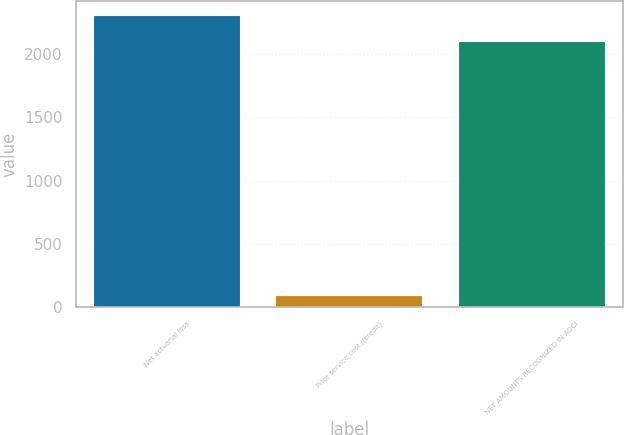<chart> <loc_0><loc_0><loc_500><loc_500><bar_chart><fcel>Net actuarial loss<fcel>Prior service cost /(credit)<fcel>NET AMOUNTS RECOGNIZED IN AOCI<nl><fcel>2297.9<fcel>92<fcel>2089<nl></chart> 